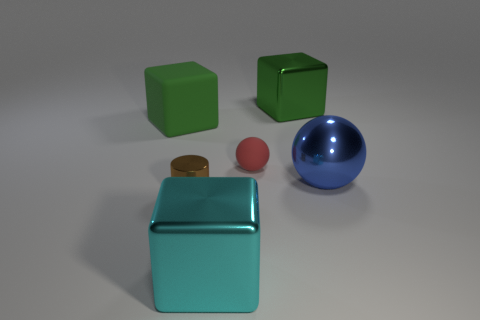Subtract all purple balls. Subtract all cyan cubes. How many balls are left? 2 Add 1 big green rubber blocks. How many objects exist? 7 Subtract all cylinders. How many objects are left? 5 Subtract all tiny brown shiny cylinders. Subtract all cyan shiny things. How many objects are left? 4 Add 6 matte objects. How many matte objects are left? 8 Add 2 big metal cubes. How many big metal cubes exist? 4 Subtract 0 purple cylinders. How many objects are left? 6 